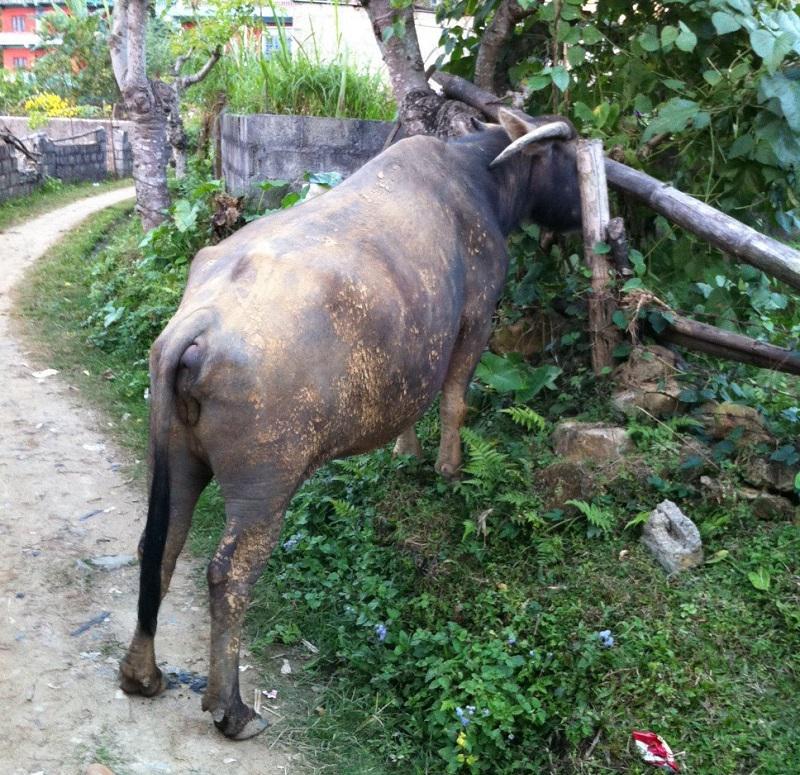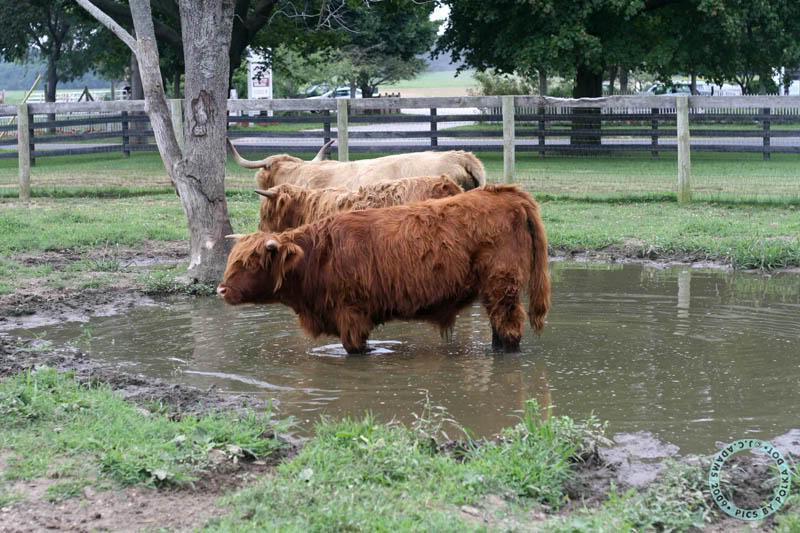The first image is the image on the left, the second image is the image on the right. Analyze the images presented: Is the assertion "There is a total of 1 buffalo in water up to their head." valid? Answer yes or no. No. The first image is the image on the left, the second image is the image on the right. Evaluate the accuracy of this statement regarding the images: "a water buffalo is up to it's neck in water". Is it true? Answer yes or no. No. 